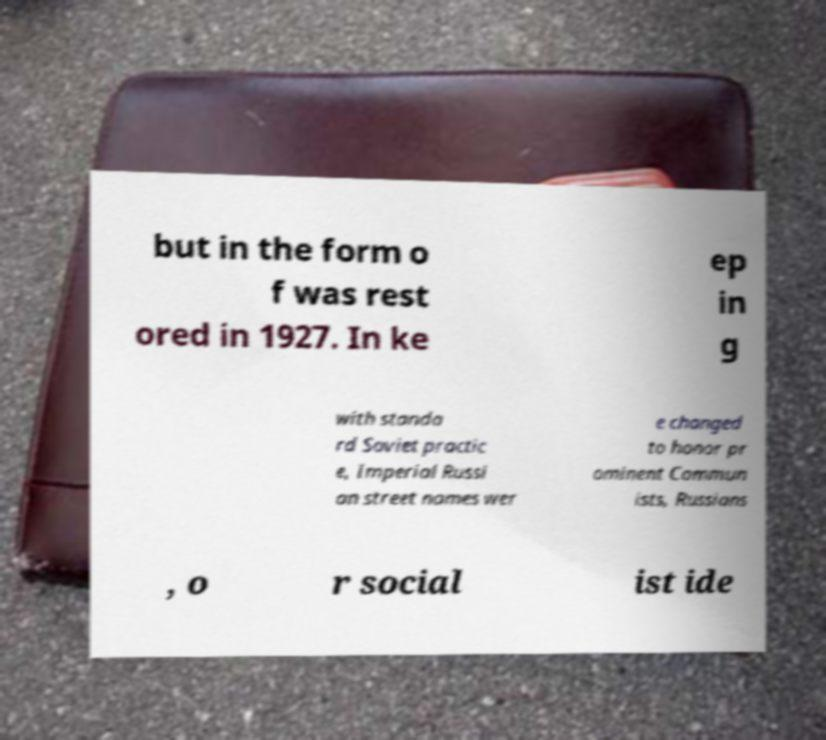What messages or text are displayed in this image? I need them in a readable, typed format. but in the form o f was rest ored in 1927. In ke ep in g with standa rd Soviet practic e, Imperial Russi an street names wer e changed to honor pr ominent Commun ists, Russians , o r social ist ide 